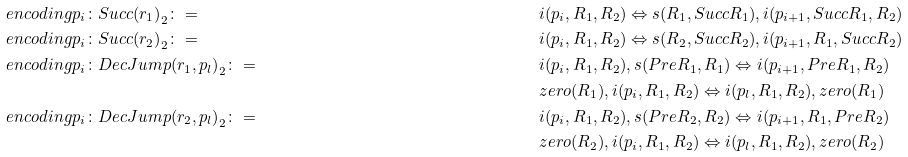<formula> <loc_0><loc_0><loc_500><loc_500>& \ e n c o d i n g { p _ { i } \colon S u c c ( r _ { 1 } ) } _ { 2 } \colon = & & i ( p _ { i } , R _ { 1 } , R _ { 2 } ) \Leftrightarrow s ( R _ { 1 } , S u c c R _ { 1 } ) , i ( p _ { i + 1 } , S u c c R _ { 1 } , R _ { 2 } ) \\ & \ e n c o d i n g { p _ { i } \colon S u c c ( r _ { 2 } ) } _ { 2 } \colon = & & i ( p _ { i } , R _ { 1 } , R _ { 2 } ) \Leftrightarrow s ( R _ { 2 } , S u c c R _ { 2 } ) , i ( p _ { i + 1 } , R _ { 1 } , S u c c R _ { 2 } ) \\ & \ e n c o d i n g { p _ { i } \colon D e c J u m p ( r _ { 1 } , p _ { l } ) } _ { 2 } \colon = & & i ( p _ { i } , R _ { 1 } , R _ { 2 } ) , s ( P r e R _ { 1 } , R _ { 1 } ) \Leftrightarrow i ( p _ { i + 1 } , P r e R _ { 1 } , R _ { 2 } ) \\ & & & z e r o ( R _ { 1 } ) , i ( p _ { i } , R _ { 1 } , R _ { 2 } ) \Leftrightarrow i ( p _ { l } , R _ { 1 } , R _ { 2 } ) , z e r o ( R _ { 1 } ) \\ & \ e n c o d i n g { p _ { i } \colon D e c J u m p ( r _ { 2 } , p _ { l } ) } _ { 2 } \colon = & & i ( p _ { i } , R _ { 1 } , R _ { 2 } ) , s ( P r e R _ { 2 } , R _ { 2 } ) \Leftrightarrow i ( p _ { i + 1 } , R _ { 1 } , P r e R _ { 2 } ) \\ & & & z e r o ( R _ { 2 } ) , i ( p _ { i } , R _ { 1 } , R _ { 2 } ) \Leftrightarrow i ( p _ { l } , R _ { 1 } , R _ { 2 } ) , z e r o ( R _ { 2 } )</formula> 